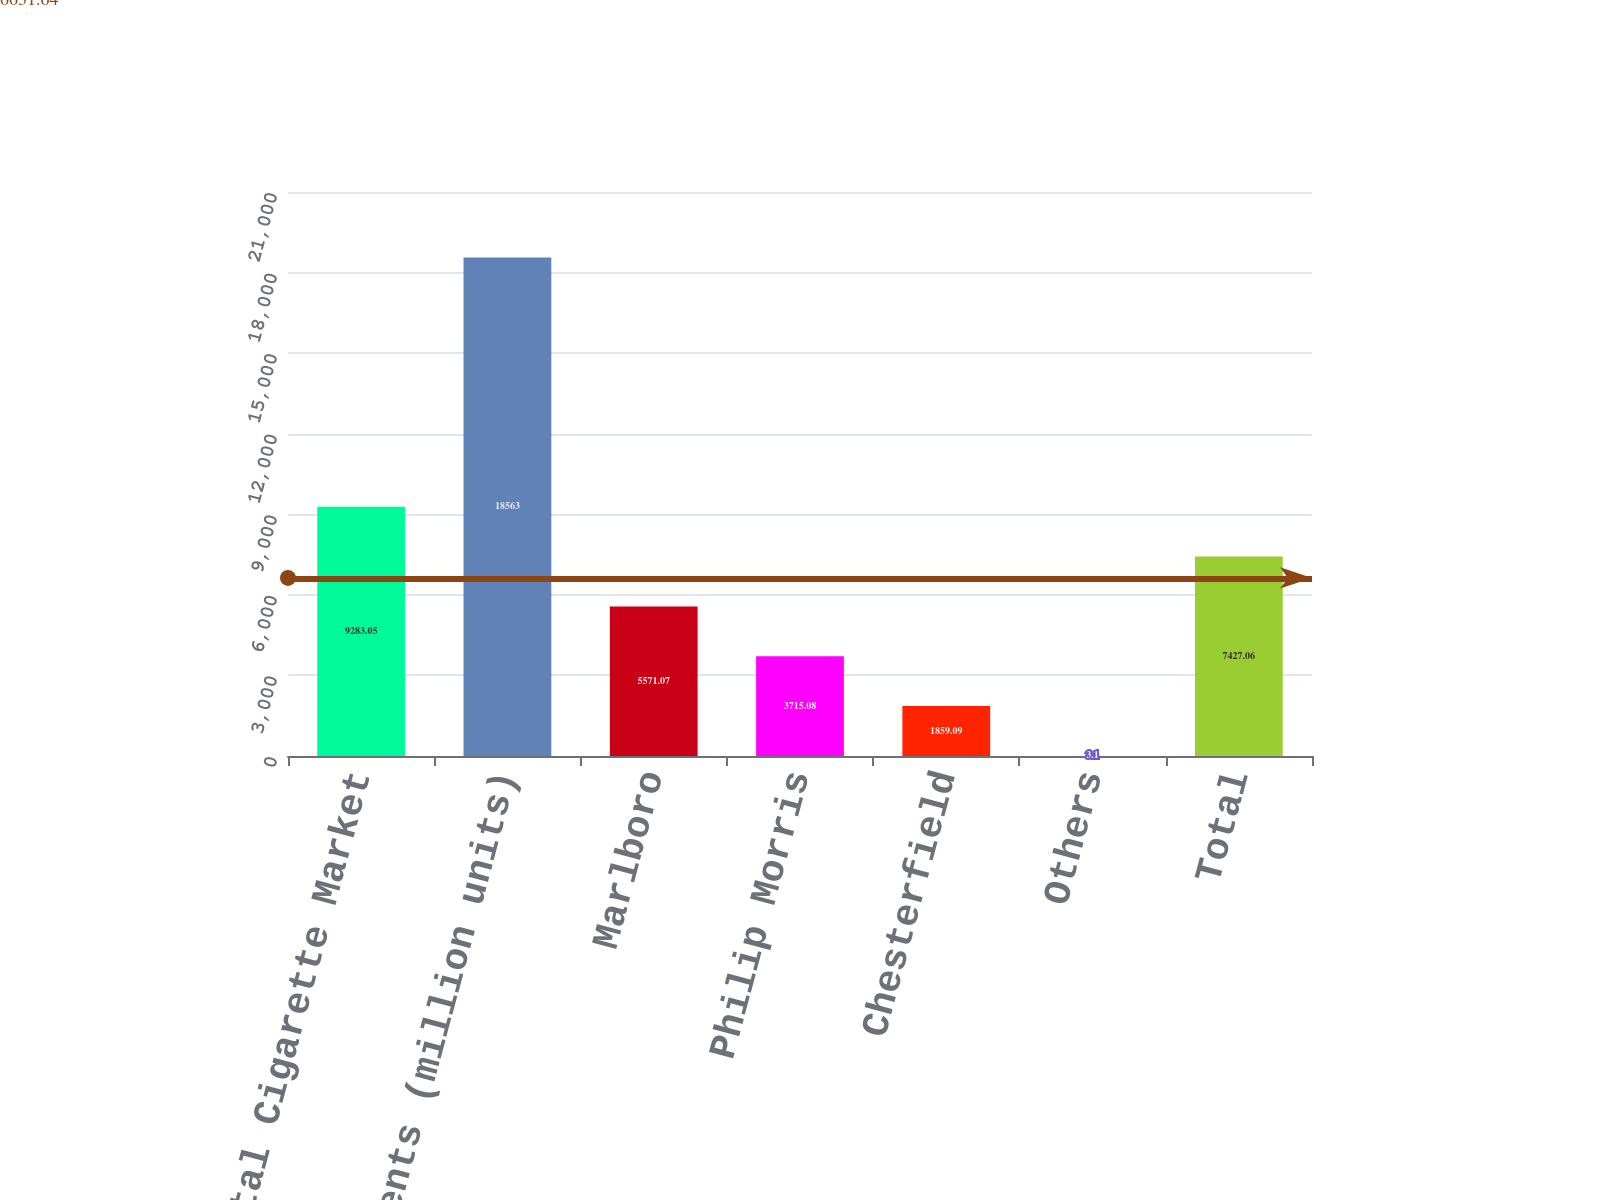Convert chart to OTSL. <chart><loc_0><loc_0><loc_500><loc_500><bar_chart><fcel>Total Cigarette Market<fcel>PMI Shipments (million units)<fcel>Marlboro<fcel>Philip Morris<fcel>Chesterfield<fcel>Others<fcel>Total<nl><fcel>9283.05<fcel>18563<fcel>5571.07<fcel>3715.08<fcel>1859.09<fcel>3.1<fcel>7427.06<nl></chart> 